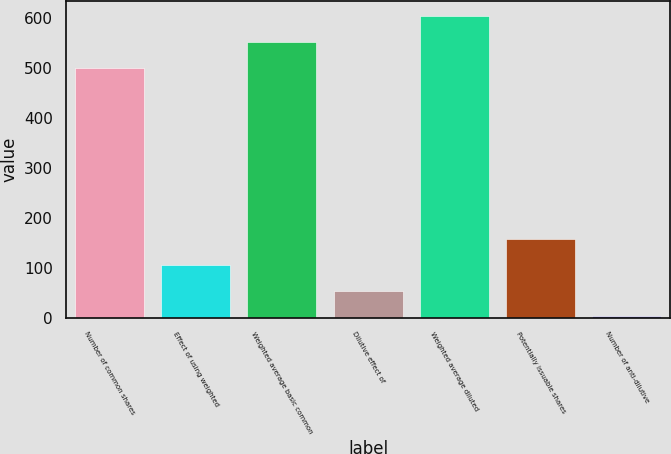Convert chart. <chart><loc_0><loc_0><loc_500><loc_500><bar_chart><fcel>Number of common shares<fcel>Effect of using weighted<fcel>Weighted average basic common<fcel>Dilutive effect of<fcel>Weighted average diluted<fcel>Potentially issuable shares<fcel>Number of anti-dilutive<nl><fcel>500.1<fcel>106.28<fcel>552.04<fcel>54.34<fcel>603.98<fcel>158.22<fcel>2.4<nl></chart> 